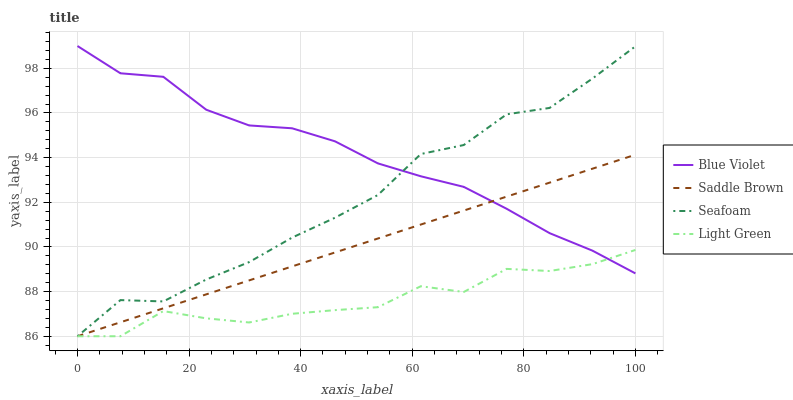Does Saddle Brown have the minimum area under the curve?
Answer yes or no. No. Does Saddle Brown have the maximum area under the curve?
Answer yes or no. No. Is Blue Violet the smoothest?
Answer yes or no. No. Is Blue Violet the roughest?
Answer yes or no. No. Does Blue Violet have the lowest value?
Answer yes or no. No. Does Saddle Brown have the highest value?
Answer yes or no. No. 